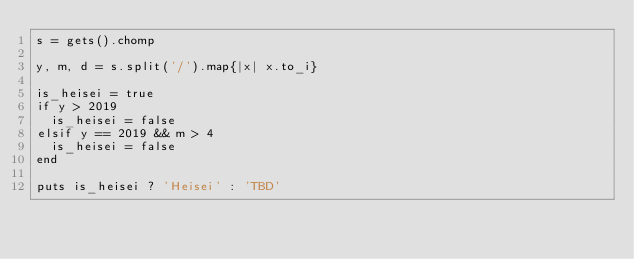Convert code to text. <code><loc_0><loc_0><loc_500><loc_500><_Ruby_>s = gets().chomp

y, m, d = s.split('/').map{|x| x.to_i}

is_heisei = true
if y > 2019
  is_heisei = false
elsif y == 2019 && m > 4
  is_heisei = false
end

puts is_heisei ? 'Heisei' : 'TBD'
</code> 